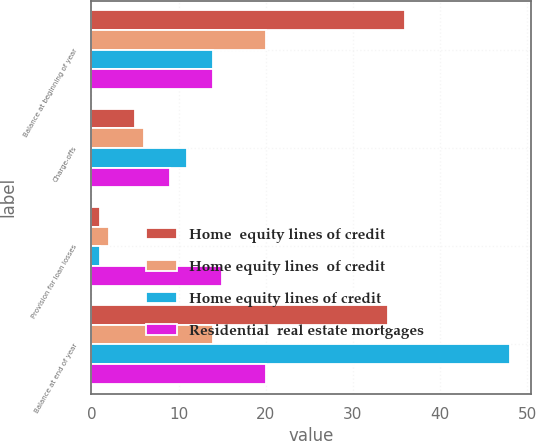Convert chart. <chart><loc_0><loc_0><loc_500><loc_500><stacked_bar_chart><ecel><fcel>Balance at beginning of year<fcel>Charge-offs<fcel>Provision for loan losses<fcel>Balance at end of year<nl><fcel>Home  equity lines of credit<fcel>36<fcel>5<fcel>1<fcel>34<nl><fcel>Home equity lines  of credit<fcel>20<fcel>6<fcel>2<fcel>14<nl><fcel>Home equity lines of credit<fcel>14<fcel>11<fcel>1<fcel>48<nl><fcel>Residential  real estate mortgages<fcel>14<fcel>9<fcel>15<fcel>20<nl></chart> 